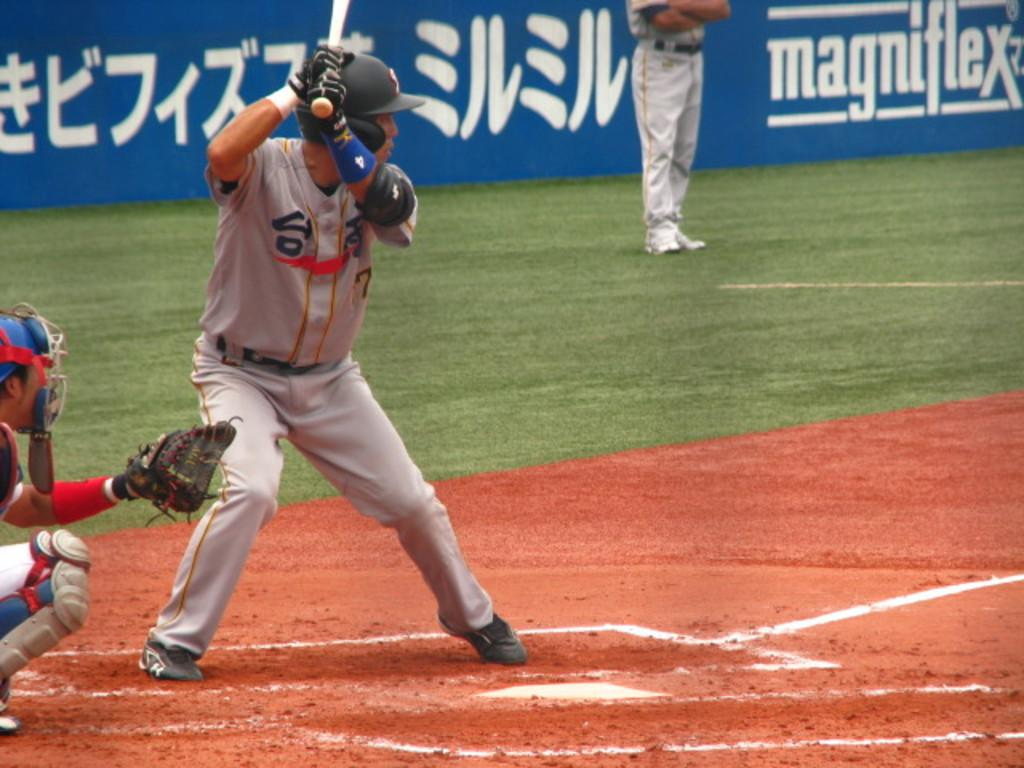<image>
Offer a succinct explanation of the picture presented. An ad for magniflex lines a blue wall on the field 